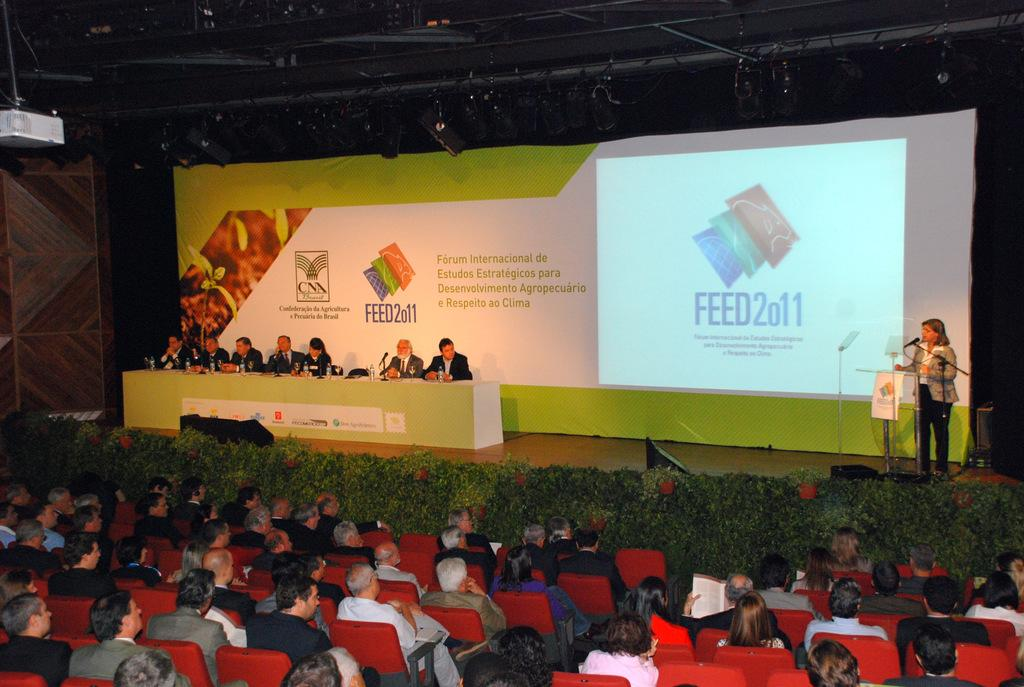How many people are present in the image? There are many people in the image. What are the people doing in the image? The people are sitting on chairs. What is the woman on the stage doing? The woman is standing on a stage. What are the people looking at on the stage? The people are looking at the woman on the stage. What type of sock is the woman on the stage wearing? There is no information about the woman's socks in the image, so we cannot determine what type of sock she is wearing. What vegetables are being served to the people in the image? There is no mention of vegetables or food in the image; it primarily focuses on the people sitting and the woman on the stage. 